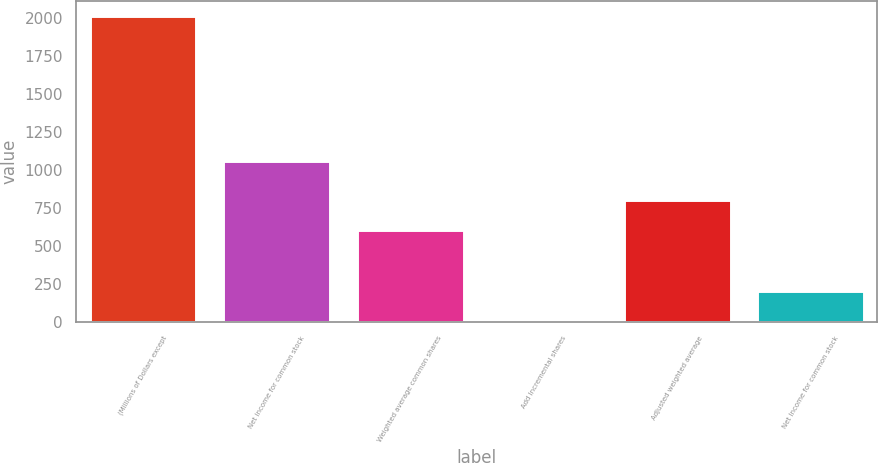<chart> <loc_0><loc_0><loc_500><loc_500><bar_chart><fcel>(Millions of Dollars except<fcel>Net income for common stock<fcel>Weighted average common shares<fcel>Add Incremental shares<fcel>Adjusted weighted average<fcel>Net Income for common stock<nl><fcel>2013<fcel>1062<fcel>604.95<fcel>1.5<fcel>806.1<fcel>202.65<nl></chart> 